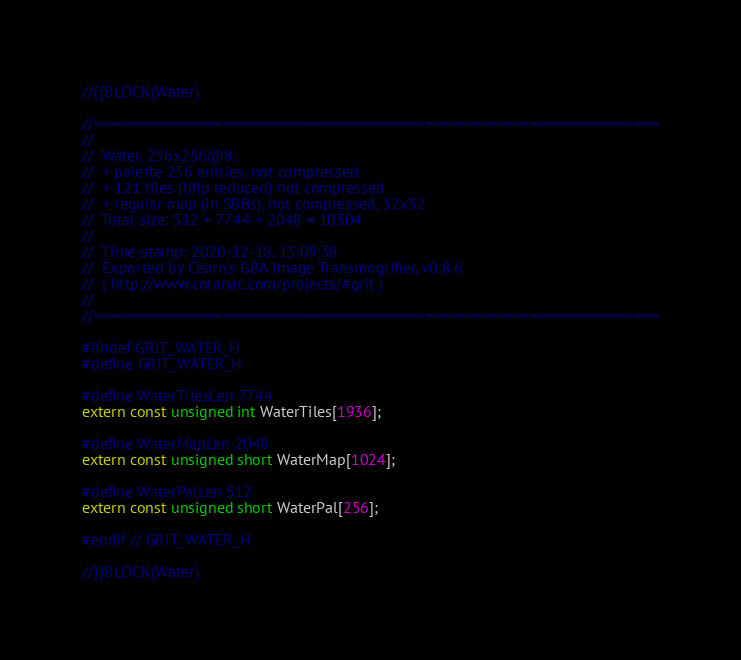Convert code to text. <code><loc_0><loc_0><loc_500><loc_500><_C_>
//{{BLOCK(Water)

//======================================================================
//
//	Water, 256x256@8, 
//	+ palette 256 entries, not compressed
//	+ 121 tiles (t|f|p reduced) not compressed
//	+ regular map (in SBBs), not compressed, 32x32 
//	Total size: 512 + 7744 + 2048 = 10304
//
//	Time-stamp: 2020-12-18, 15:09:38
//	Exported by Cearn's GBA Image Transmogrifier, v0.8.6
//	( http://www.coranac.com/projects/#grit )
//
//======================================================================

#ifndef GRIT_WATER_H
#define GRIT_WATER_H

#define WaterTilesLen 7744
extern const unsigned int WaterTiles[1936];

#define WaterMapLen 2048
extern const unsigned short WaterMap[1024];

#define WaterPalLen 512
extern const unsigned short WaterPal[256];

#endif // GRIT_WATER_H

//}}BLOCK(Water)
</code> 